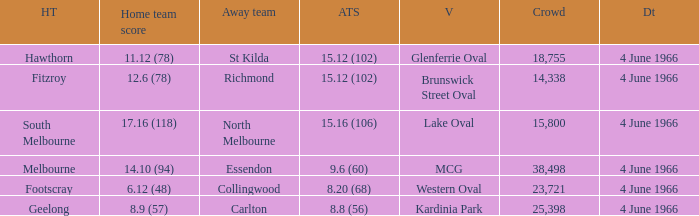What is the largest crowd size that watch a game where the home team scored 12.6 (78)? 14338.0. 